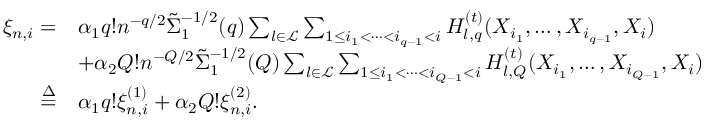Convert formula to latex. <formula><loc_0><loc_0><loc_500><loc_500>\begin{array} { r l } { \xi _ { n , i } = } & { \alpha _ { 1 } q ! n ^ { - q / 2 } \tilde { \Sigma } _ { 1 } ^ { - 1 / 2 } ( q ) \sum _ { l \in \mathcal { L } } \sum _ { 1 \leq i _ { 1 } < \cdots < i _ { q - 1 } < i } H _ { l , q } ^ { ( t ) } ( X _ { i _ { 1 } } , \dots , X _ { i _ { q - 1 } } , X _ { i } ) } \\ & { + \alpha _ { 2 } Q ! n ^ { - Q / 2 } \tilde { \Sigma } _ { 1 } ^ { - 1 / 2 } ( Q ) \sum _ { l \in \mathcal { L } } \sum _ { 1 \leq i _ { 1 } < \cdots < i _ { Q - 1 } < i } H _ { l , Q } ^ { ( t ) } ( X _ { i _ { 1 } } , \dots , X _ { i _ { Q - 1 } } , X _ { i } ) } \\ { \overset { \Delta } { = } } & { \alpha _ { 1 } q ! \xi _ { n , i } ^ { ( 1 ) } + \alpha _ { 2 } Q ! \xi _ { n , i } ^ { ( 2 ) } . } \end{array}</formula> 